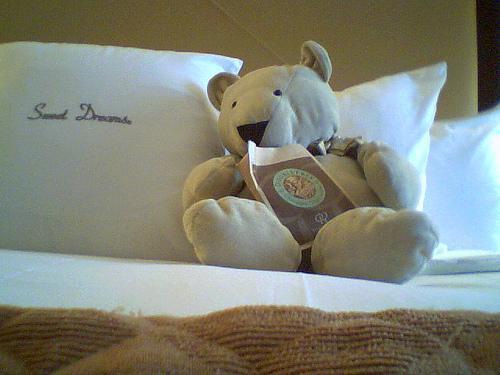How many toys are there?
Give a very brief answer. 1. How many beds are there?
Give a very brief answer. 2. How many people are on the stairs?
Give a very brief answer. 0. 